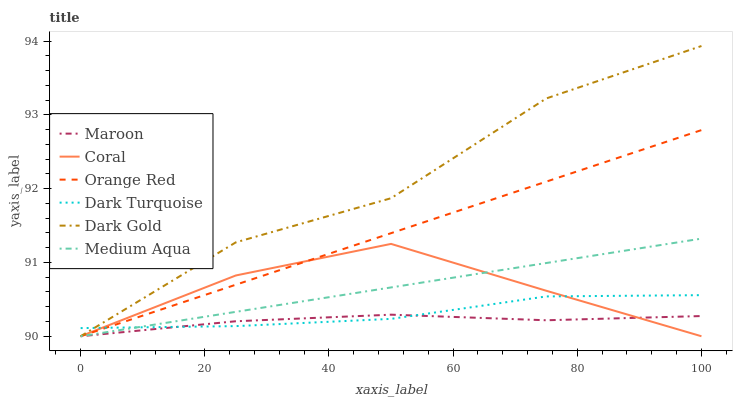Does Maroon have the minimum area under the curve?
Answer yes or no. Yes. Does Dark Gold have the maximum area under the curve?
Answer yes or no. Yes. Does Dark Turquoise have the minimum area under the curve?
Answer yes or no. No. Does Dark Turquoise have the maximum area under the curve?
Answer yes or no. No. Is Orange Red the smoothest?
Answer yes or no. Yes. Is Dark Gold the roughest?
Answer yes or no. Yes. Is Dark Turquoise the smoothest?
Answer yes or no. No. Is Dark Turquoise the roughest?
Answer yes or no. No. Does Dark Gold have the lowest value?
Answer yes or no. Yes. Does Dark Turquoise have the lowest value?
Answer yes or no. No. Does Dark Gold have the highest value?
Answer yes or no. Yes. Does Dark Turquoise have the highest value?
Answer yes or no. No. Does Orange Red intersect Dark Turquoise?
Answer yes or no. Yes. Is Orange Red less than Dark Turquoise?
Answer yes or no. No. Is Orange Red greater than Dark Turquoise?
Answer yes or no. No. 